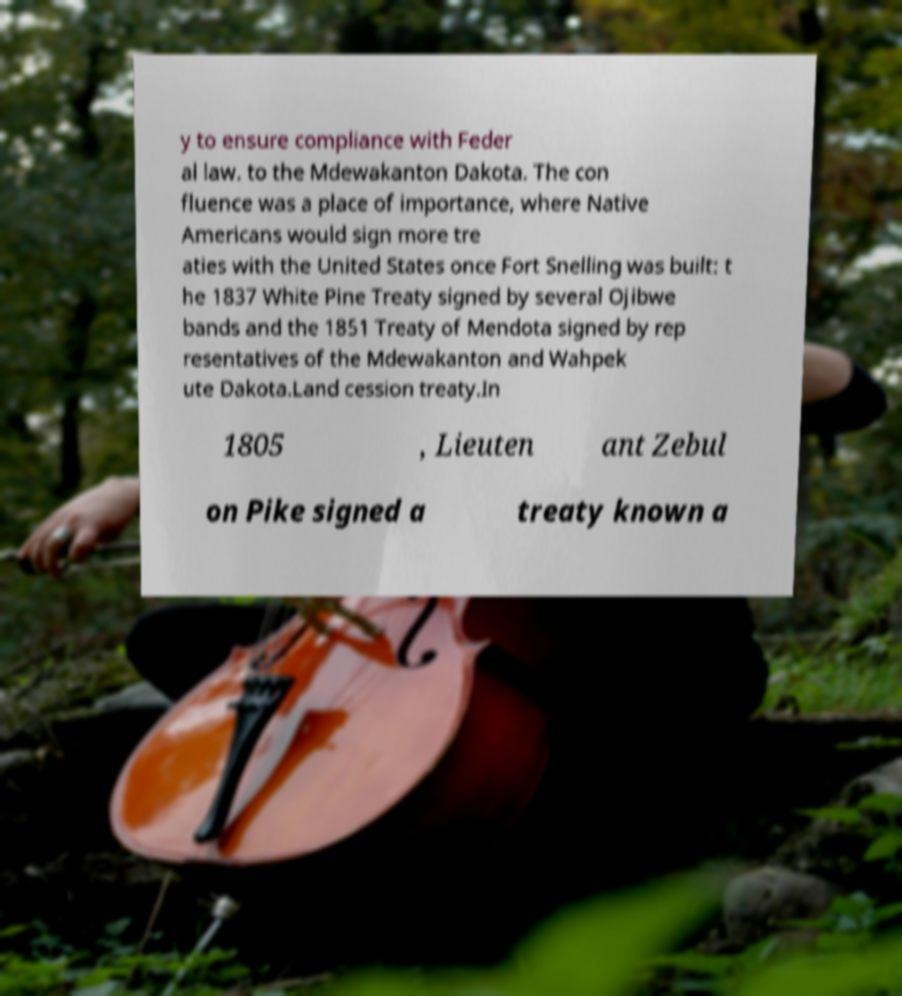For documentation purposes, I need the text within this image transcribed. Could you provide that? y to ensure compliance with Feder al law. to the Mdewakanton Dakota. The con fluence was a place of importance, where Native Americans would sign more tre aties with the United States once Fort Snelling was built: t he 1837 White Pine Treaty signed by several Ojibwe bands and the 1851 Treaty of Mendota signed by rep resentatives of the Mdewakanton and Wahpek ute Dakota.Land cession treaty.In 1805 , Lieuten ant Zebul on Pike signed a treaty known a 